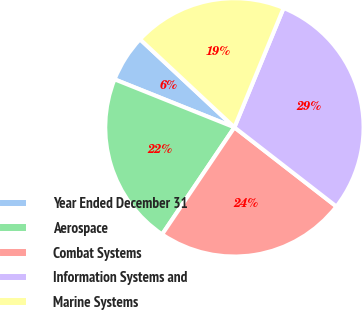Convert chart. <chart><loc_0><loc_0><loc_500><loc_500><pie_chart><fcel>Year Ended December 31<fcel>Aerospace<fcel>Combat Systems<fcel>Information Systems and<fcel>Marine Systems<nl><fcel>5.88%<fcel>21.61%<fcel>23.95%<fcel>29.28%<fcel>19.27%<nl></chart> 